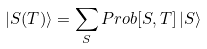Convert formula to latex. <formula><loc_0><loc_0><loc_500><loc_500>| { S } ( T ) \rangle = \sum _ { S } P r o b [ { S } , T ] \, | { S } \rangle</formula> 